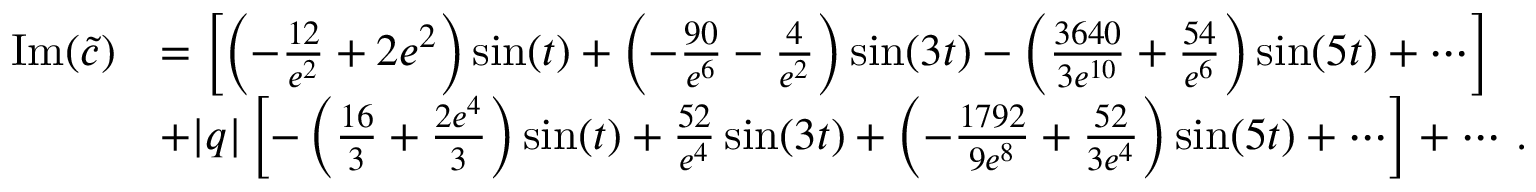<formula> <loc_0><loc_0><loc_500><loc_500>\begin{array} { r l } { I m ( \widetilde { c } ) } & { = \left [ \left ( - { \frac { 1 2 } { e ^ { 2 } } } + 2 e ^ { 2 } \right ) \sin ( t ) + \left ( - { \frac { 9 0 } { e ^ { 6 } } } - { \frac { 4 } { e ^ { 2 } } } \right ) \sin ( 3 t ) - \left ( { \frac { 3 6 4 0 } { 3 e ^ { 1 0 } } } + { \frac { 5 4 } { e ^ { 6 } } } \right ) \sin ( 5 t ) + \cdots \right ] } \\ & { + | q | \left [ - \left ( { \frac { 1 6 } { 3 } } + { \frac { 2 e ^ { 4 } } { 3 } } \right ) \sin ( t ) + { \frac { 5 2 } { e ^ { 4 } } } \sin ( 3 t ) + \left ( - { \frac { 1 7 9 2 } { 9 e ^ { 8 } } } + { \frac { 5 2 } { 3 e ^ { 4 } } } \right ) \sin ( 5 t ) + \cdots \right ] + \cdots \, . } \end{array}</formula> 